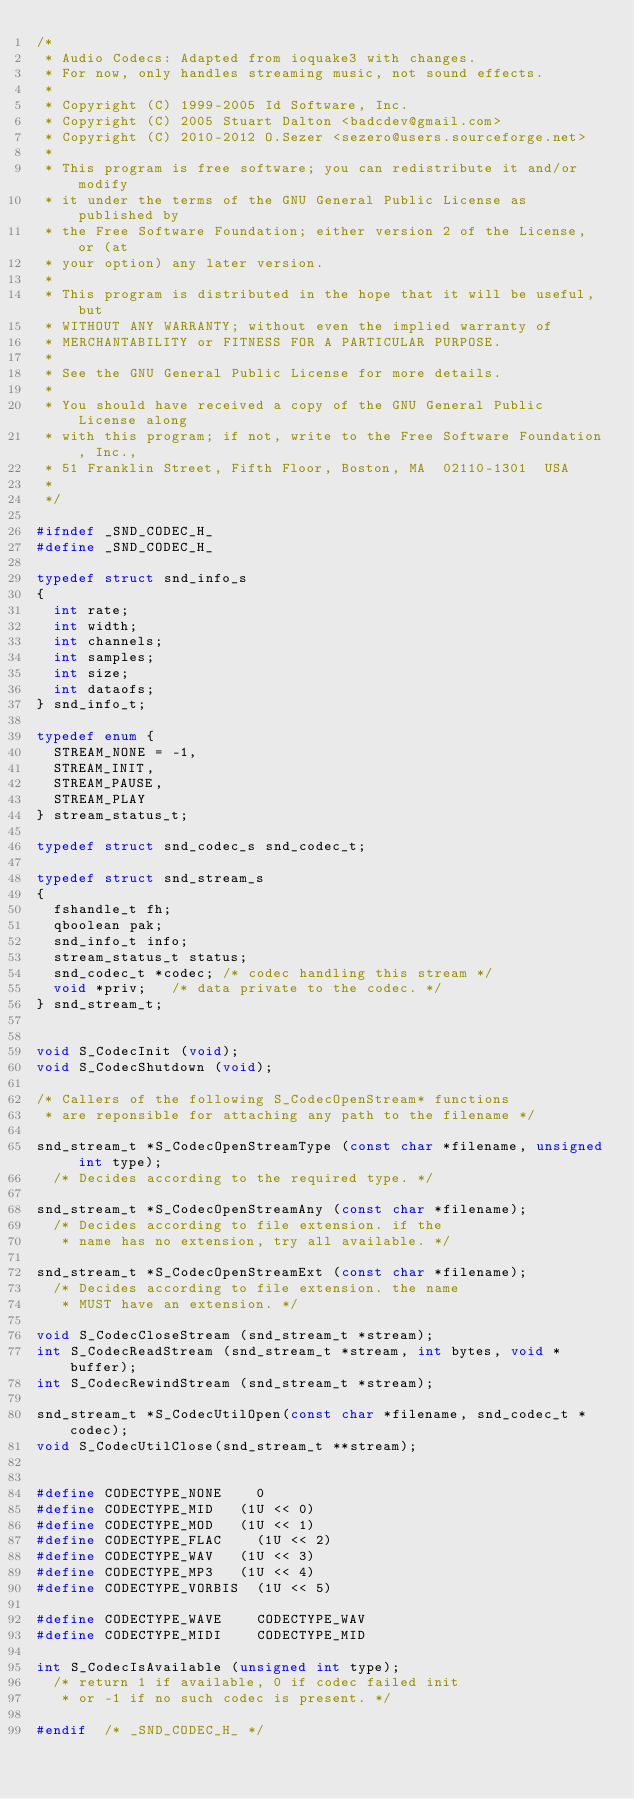Convert code to text. <code><loc_0><loc_0><loc_500><loc_500><_C_>/*
 * Audio Codecs: Adapted from ioquake3 with changes.
 * For now, only handles streaming music, not sound effects.
 *
 * Copyright (C) 1999-2005 Id Software, Inc.
 * Copyright (C) 2005 Stuart Dalton <badcdev@gmail.com>
 * Copyright (C) 2010-2012 O.Sezer <sezero@users.sourceforge.net>
 *
 * This program is free software; you can redistribute it and/or modify
 * it under the terms of the GNU General Public License as published by
 * the Free Software Foundation; either version 2 of the License, or (at
 * your option) any later version.
 *
 * This program is distributed in the hope that it will be useful, but
 * WITHOUT ANY WARRANTY; without even the implied warranty of
 * MERCHANTABILITY or FITNESS FOR A PARTICULAR PURPOSE.
 *
 * See the GNU General Public License for more details.
 *
 * You should have received a copy of the GNU General Public License along
 * with this program; if not, write to the Free Software Foundation, Inc.,
 * 51 Franklin Street, Fifth Floor, Boston, MA  02110-1301  USA
 *
 */

#ifndef _SND_CODEC_H_
#define _SND_CODEC_H_

typedef struct snd_info_s
{
	int rate;
	int width;
	int channels;
	int samples;
	int size;
	int dataofs;
} snd_info_t;

typedef enum {
	STREAM_NONE = -1,
	STREAM_INIT,
	STREAM_PAUSE,
	STREAM_PLAY
} stream_status_t;

typedef struct snd_codec_s snd_codec_t;

typedef struct snd_stream_s
{
	fshandle_t fh;
	qboolean pak;
	snd_info_t info;
	stream_status_t status;
	snd_codec_t *codec;	/* codec handling this stream */
	void *priv;		/* data private to the codec. */
} snd_stream_t;


void S_CodecInit (void);
void S_CodecShutdown (void);

/* Callers of the following S_CodecOpenStream* functions
 * are reponsible for attaching any path to the filename */

snd_stream_t *S_CodecOpenStreamType (const char *filename, unsigned int type);
	/* Decides according to the required type. */

snd_stream_t *S_CodecOpenStreamAny (const char *filename);
	/* Decides according to file extension. if the
	 * name has no extension, try all available. */

snd_stream_t *S_CodecOpenStreamExt (const char *filename);
	/* Decides according to file extension. the name
	 * MUST have an extension. */

void S_CodecCloseStream (snd_stream_t *stream);
int S_CodecReadStream (snd_stream_t *stream, int bytes, void *buffer);
int S_CodecRewindStream (snd_stream_t *stream);

snd_stream_t *S_CodecUtilOpen(const char *filename, snd_codec_t *codec);
void S_CodecUtilClose(snd_stream_t **stream);


#define CODECTYPE_NONE		0
#define CODECTYPE_MID		(1U << 0)
#define CODECTYPE_MOD		(1U << 1)
#define CODECTYPE_FLAC		(1U << 2)
#define CODECTYPE_WAV		(1U << 3)
#define CODECTYPE_MP3		(1U << 4)
#define CODECTYPE_VORBIS	(1U << 5)

#define CODECTYPE_WAVE		CODECTYPE_WAV
#define CODECTYPE_MIDI		CODECTYPE_MID

int S_CodecIsAvailable (unsigned int type);
	/* return 1 if available, 0 if codec failed init
	 * or -1 if no such codec is present. */

#endif	/* _SND_CODEC_H_ */

</code> 